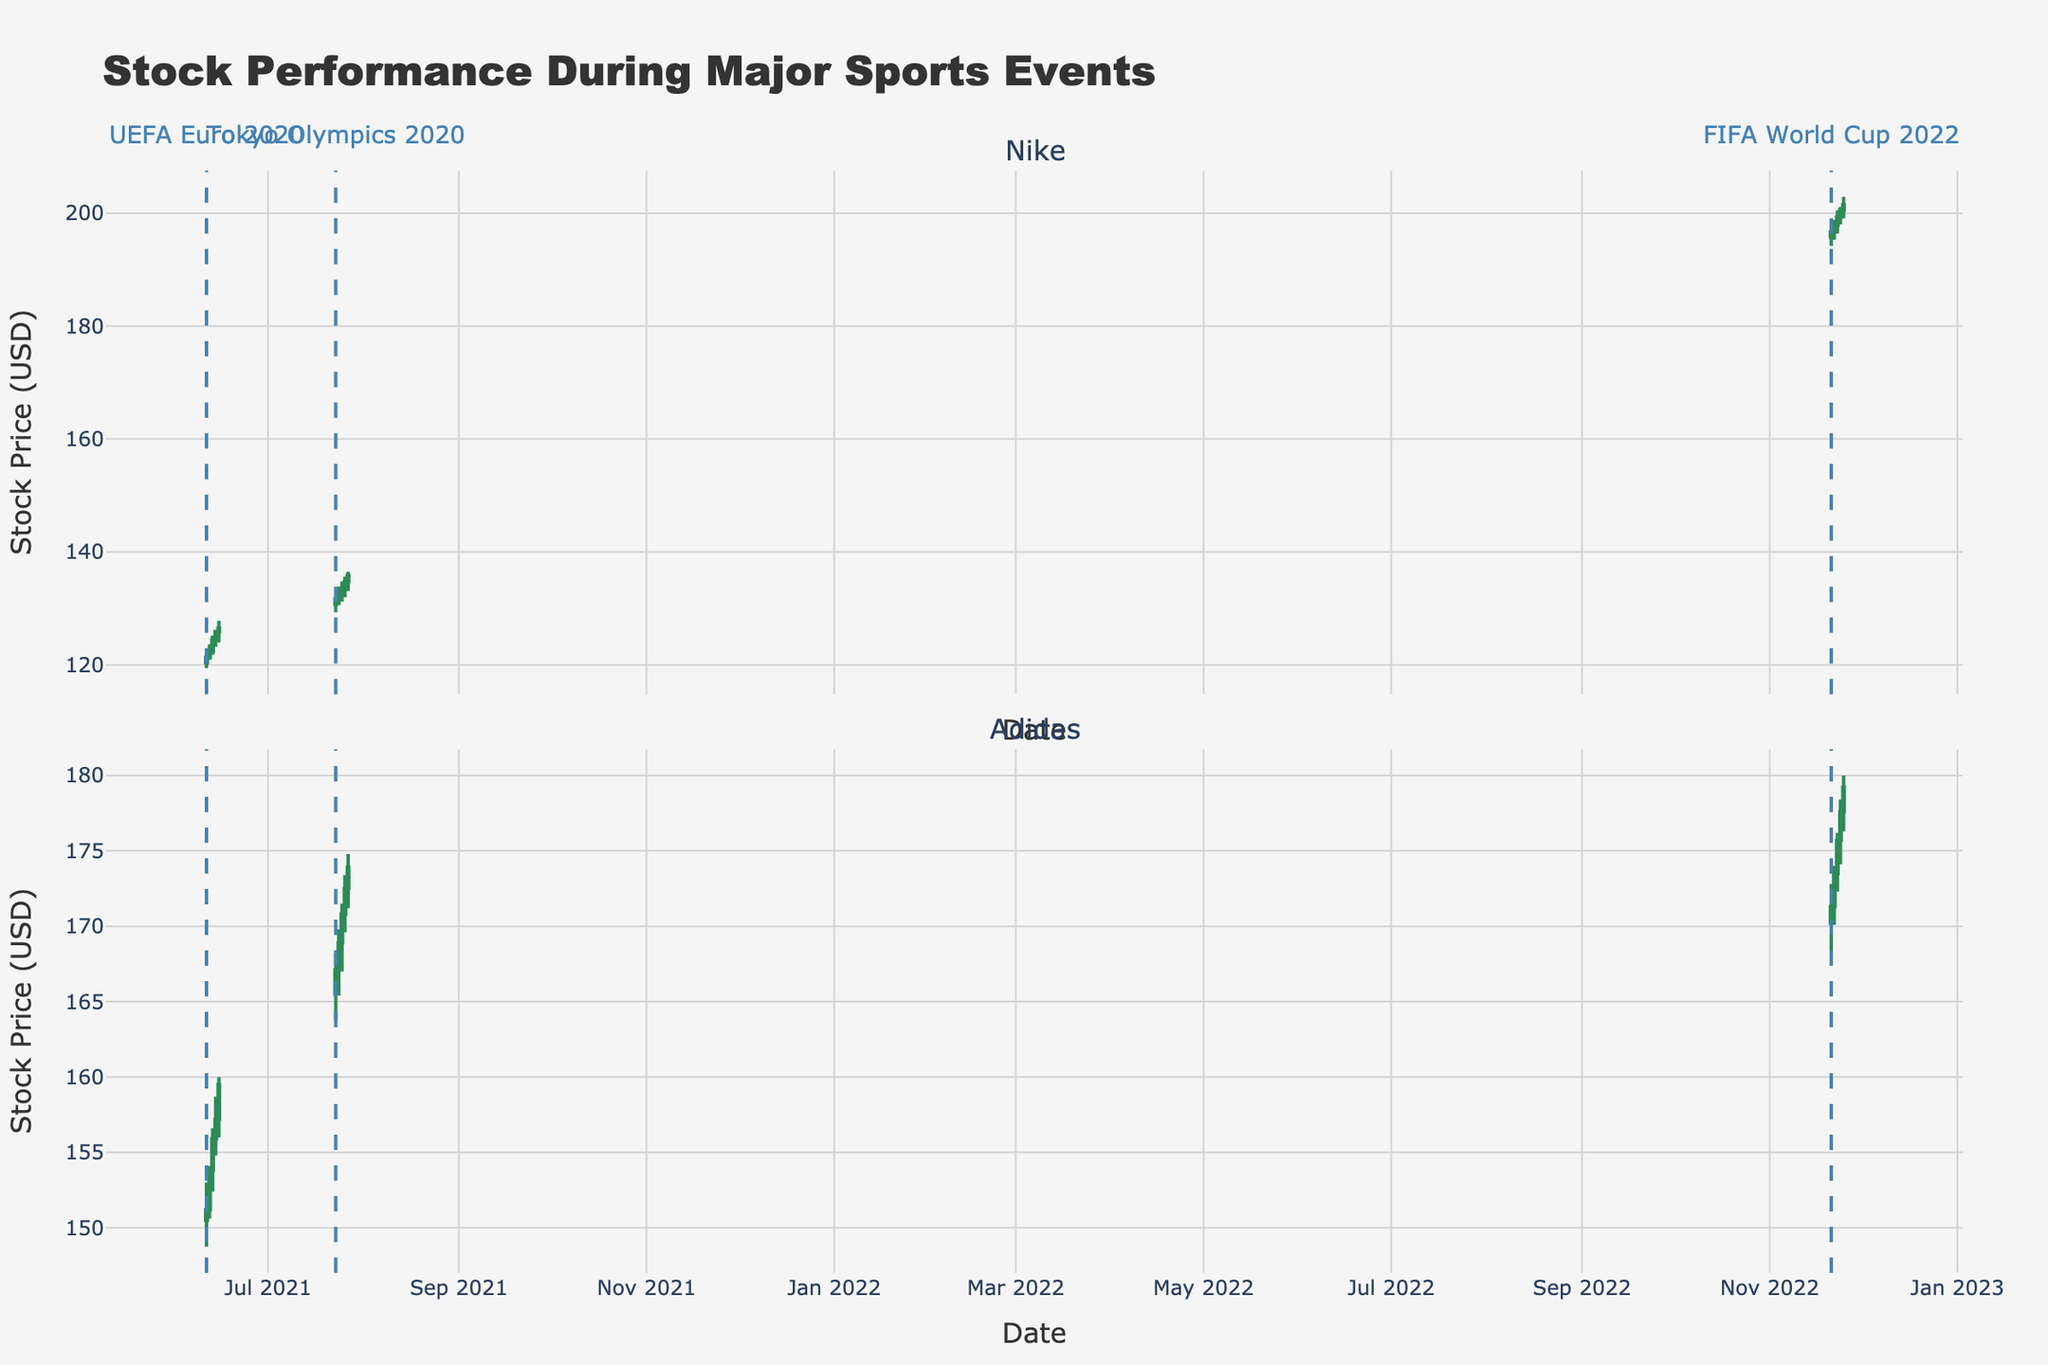How many days of stock data for Nike are shown in the plot during the UEFA Euro 2020 event? By looking at the "Event" labels and counting the number of unique dates for Nike during the period labeled "UEFA Euro 2020," we can see there are 5 days of data.
Answer: 5 What is the overall trend of Adidas stock price during the Tokyo Olympics 2020 event? By observing the candlestick patterns for Adidas during the days labeled "Tokyo Olympics 2020," we see that the stock price is generally increasing, as the closing prices are higher than the opening prices on most days.
Answer: Increasing On which date did Adidas achieve the highest stock price during the FIFA World Cup 2022 event? By noting the highest "High" value for Adidas during the FIFA World Cup 2022 from the candlesticks, it occurred on November 25, 2022.
Answer: November 25, 2022 Compare the closing prices of Nike and Adidas on the first day of the UEFA Euro 2020 event. Which brand had a higher closing price? By comparing the closing prices for Nike ($121.36) and Adidas ($151.20) on June 11, 2021, Adidas had the higher closing price.
Answer: Adidas During the FIFA World Cup 2022, what was the difference in the closing prices of Nike and Adidas on November 23, 2022? Nike closed at $199.30 and Adidas closed at $175.70 on November 23, 2022. The difference is $199.30 - $175.70 = $23.60
Answer: $23.60 What can we infer about the performance of Nike's stock during major sports events from the plot? By observing the candlestick trends for Nike during UEFA Euro 2020, Tokyo Olympics 2020, and FIFA World Cup 2022, all of which show overall upward trends in stock prices, we can infer that Nike's stock typically performs well during major sports events.
Answer: Nike's stock typically performs well Which brand had the largest volume of trades during the Tokyo Olympics 2020 event and on which date? By looking at the volume bars for Adidas and Nike during the Tokyo Olympics 2020 event, Adidas had the largest volume of trades on July 23, 2021, with 6,800,000 shares.
Answer: Adidas, July 23, 2021 